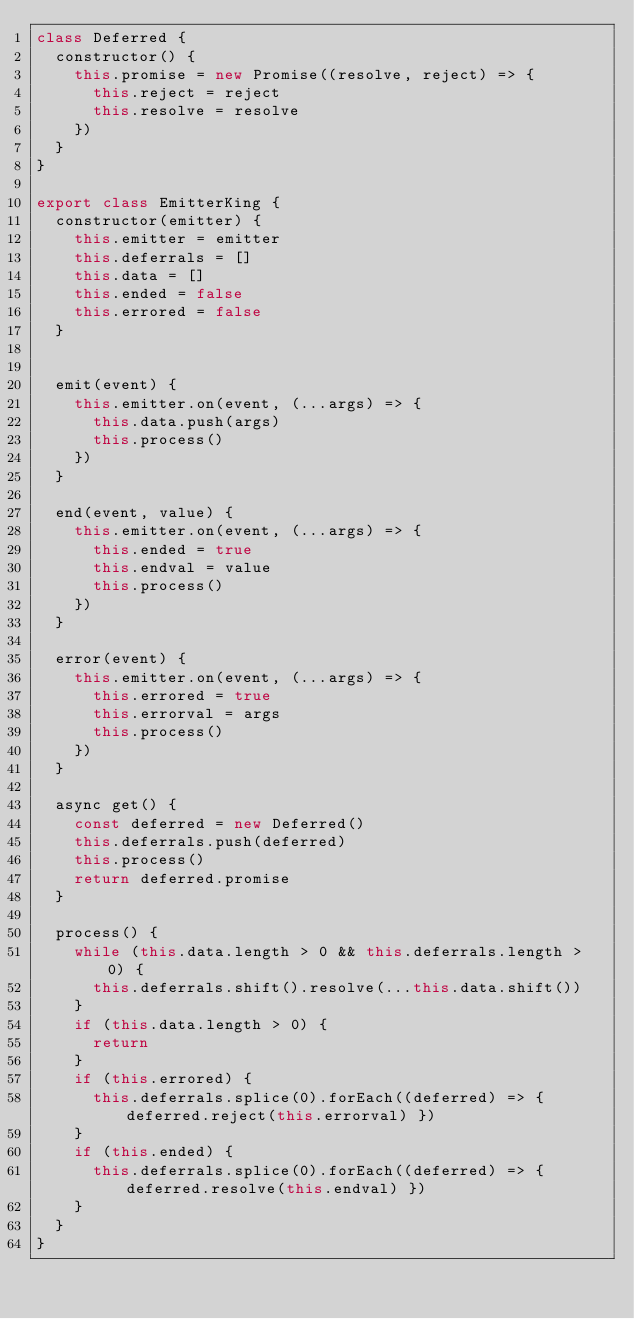<code> <loc_0><loc_0><loc_500><loc_500><_JavaScript_>class Deferred {
  constructor() {
    this.promise = new Promise((resolve, reject) => {
      this.reject = reject
      this.resolve = resolve
    })
  }
}

export class EmitterKing {
  constructor(emitter) {
    this.emitter = emitter
    this.deferrals = []
    this.data = []
    this.ended = false
    this.errored = false
  }


  emit(event) {
    this.emitter.on(event, (...args) => {
      this.data.push(args)
      this.process()
    })
  }

  end(event, value) {
    this.emitter.on(event, (...args) => {
      this.ended = true
      this.endval = value
      this.process()
    })
  }

  error(event) {
    this.emitter.on(event, (...args) => {
      this.errored = true
      this.errorval = args
      this.process()
    })
  }

  async get() {
    const deferred = new Deferred()
    this.deferrals.push(deferred)
    this.process()
    return deferred.promise
  }

  process() {
    while (this.data.length > 0 && this.deferrals.length > 0) {
      this.deferrals.shift().resolve(...this.data.shift())
    }
    if (this.data.length > 0) {
      return
    }
    if (this.errored) {
      this.deferrals.splice(0).forEach((deferred) => { deferred.reject(this.errorval) })
    }
    if (this.ended) {
      this.deferrals.splice(0).forEach((deferred) => { deferred.resolve(this.endval) })
    }
  }
}
</code> 